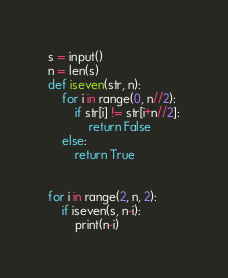<code> <loc_0><loc_0><loc_500><loc_500><_Python_>s = input()
n = len(s)
def iseven(str, n):
    for i in range(0, n//2):
        if str[i] != str[i+n//2]:
            return False
    else:
        return True


for i in range(2, n, 2):
    if iseven(s, n-i):
        print(n-i)</code> 